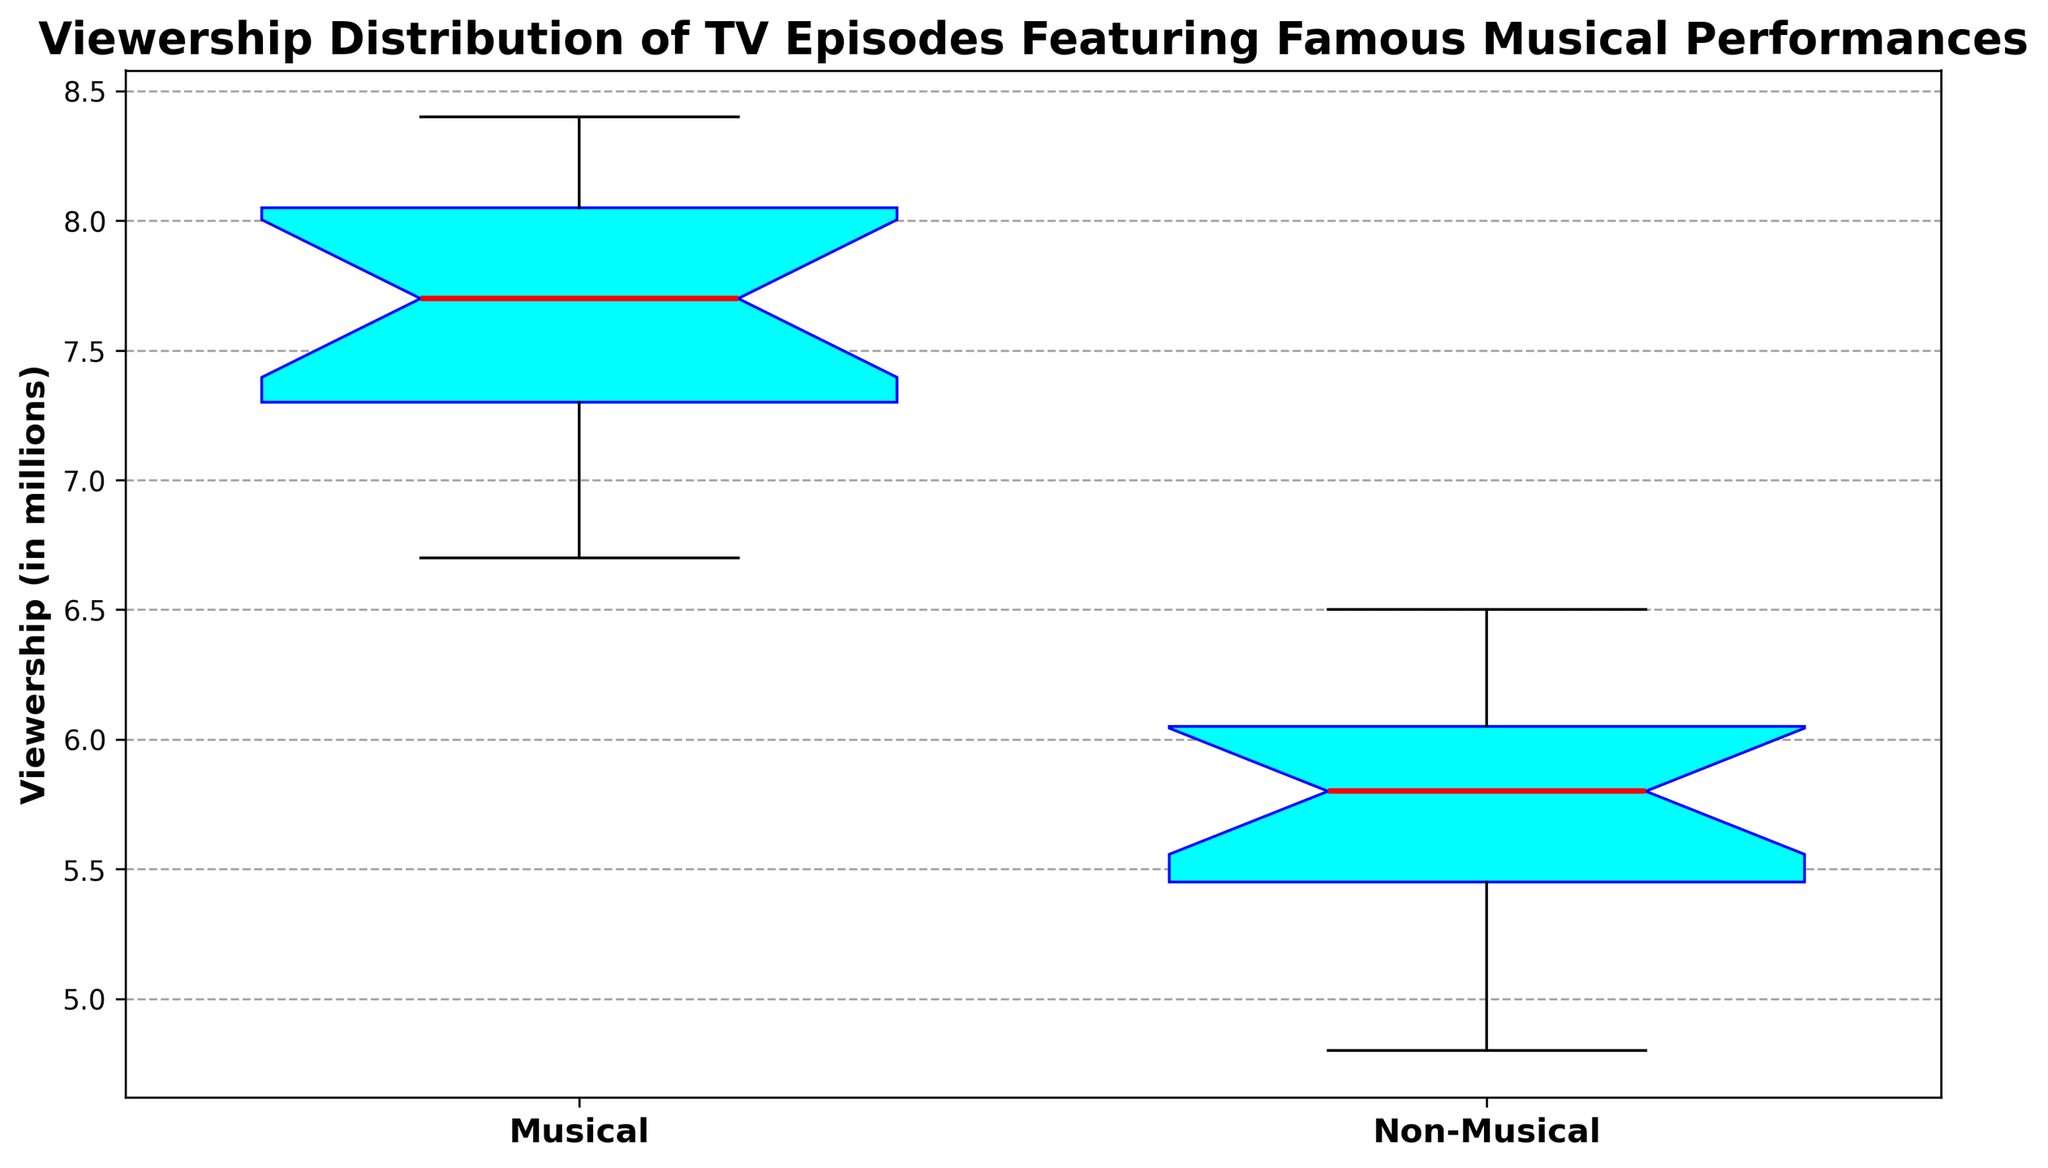What is the median viewership for Musical episodes? The median is marked by the red line in the box plot for the Musical category.
Answer: 7.6 Which category has a higher median viewership, Musical or Non-Musical episodes? The median is the red line in the box plot. The median for Musical episodes is higher than that for Non-Musical episodes.
Answer: Musical What is the interquartile range (IQR) for the Musical episodes? The IQR is the difference between the third quartile (upper edge of the box) and the first quartile (lower edge of the box). For Musical episodes, the IQR is 8.2 - 7.2.
Answer: 1.0 Are there any outliers in the Non-Musical episodes' viewership, and if yes, what are the values? Outliers are depicted as green markers. In the Non-Musical category, there are outliers below the whisker line, which is clearly marked on the box plot.
Answer: 4.8 and 5.2 What is the maximum recorded viewership for Musical episodes? The maximum value is the highest point above the upper whisker in the box plot for Musical episodes.
Answer: 8.4 Which category has a wider spread of viewership? Comparing the length of the whiskers (excluding outliers), the Musical episodes have a wider spread of viewership than the Non-Musical episodes.
Answer: Musical Is the median viewership for Non-Musical episodes closer to the 1st quartile or the 3rd quartile? By examining the box plot, the median (red line) for Non-Musical episodes is slightly closer to the 1st quartile than to the 3rd quartile.
Answer: 1st quartile What is the viewership of the episode that is an outlier in the Musical category? No outliers are marked in the box plot for the Musical category, meaning there are no exceptional high or low viewership figures.
Answer: None Between the Musical and Non-Musical episodes, which category has a more consistent viewership? Consistency in viewership can be determined by a smaller interquartile range and shorter whiskers. The Non-Musical episodes have a smaller IQR and shorter whiskers, indicating more consistency.
Answer: Non-Musical What is the approximate viewership difference between the median Musical episode and the median Non-Musical episode? Subtract the median viewership of Non-Musical episodes from that of Musical episodes: 7.6 - 6.0.
Answer: 1.6 